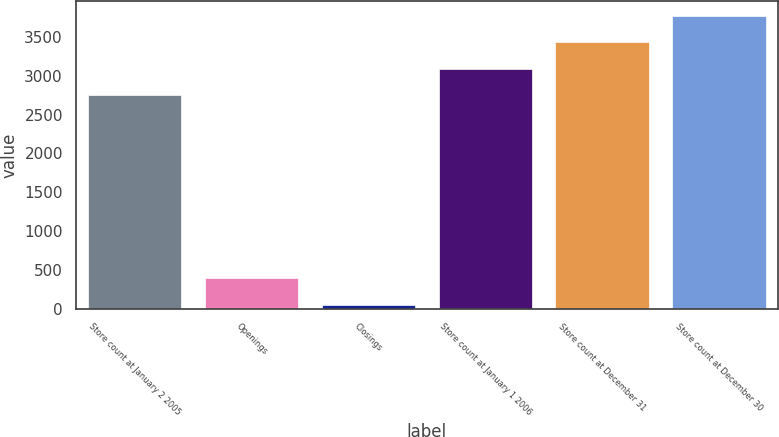Convert chart to OTSL. <chart><loc_0><loc_0><loc_500><loc_500><bar_chart><fcel>Store count at January 2 2005<fcel>Openings<fcel>Closings<fcel>Store count at January 1 2006<fcel>Store count at December 31<fcel>Store count at December 30<nl><fcel>2749<fcel>395.5<fcel>54<fcel>3090.5<fcel>3432<fcel>3773.5<nl></chart> 